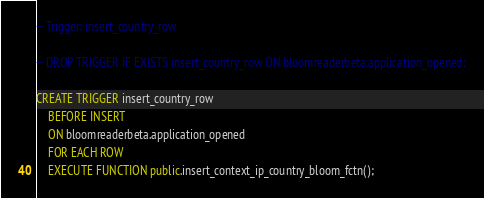<code> <loc_0><loc_0><loc_500><loc_500><_SQL_>-- Trigger: insert_country_row

-- DROP TRIGGER IF EXISTS insert_country_row ON bloomreaderbeta.application_opened;

CREATE TRIGGER insert_country_row
    BEFORE INSERT
    ON bloomreaderbeta.application_opened
    FOR EACH ROW
    EXECUTE FUNCTION public.insert_context_ip_country_bloom_fctn();</code> 